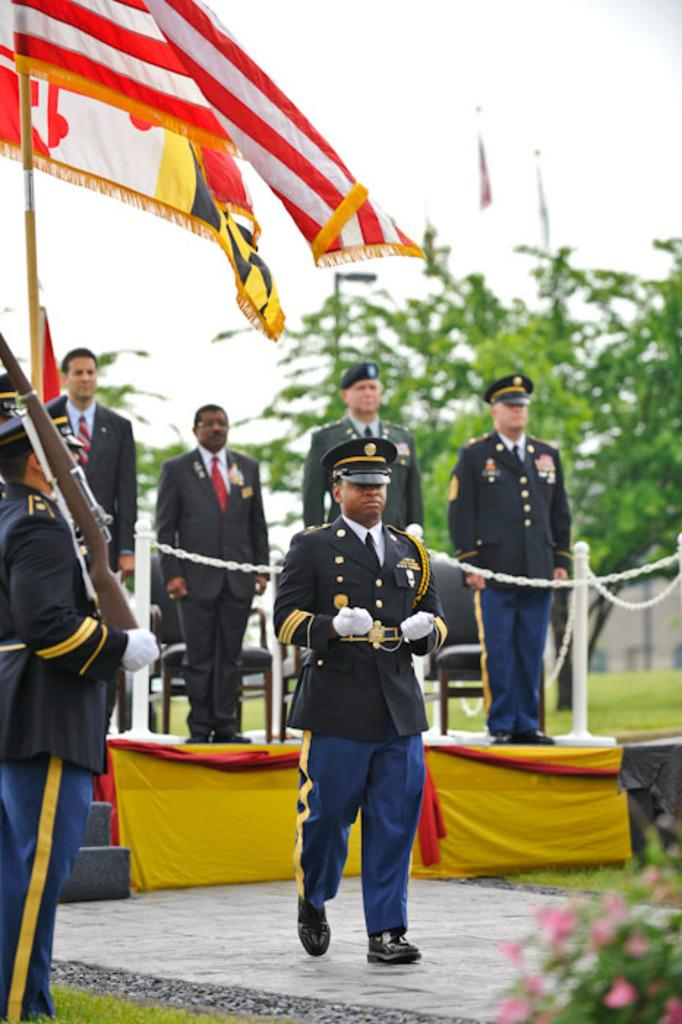How many people are in the image? There is a group of people in the image, but the exact number is not specified. What are some people doing in the image? Some people are standing on a stage, while a man is walking on the floor. What can be seen in the background of the image? There are trees are visible in the background of the image. What objects are present in the image that might be used for sitting? Chairs are present in the image for sitting. Can you tell me how many stamps are on the gun in the image? There is no mention of stamps in the image, and the gun is not described in detail. What type of snake can be seen slithering through the trees in the background? There is no snake present in the image; only trees are visible in the background. 